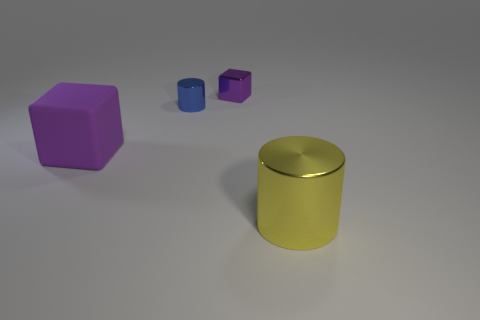There is a rubber object that is the same color as the small metal block; what is its size?
Provide a short and direct response. Large. Is the color of the rubber object the same as the small shiny block?
Your answer should be compact. Yes. Are there fewer blue cylinders that are in front of the rubber thing than large cylinders?
Offer a terse response. Yes. The cylinder that is behind the purple matte object is what color?
Offer a very short reply. Blue. What shape is the tiny blue metal thing?
Keep it short and to the point. Cylinder. Is there a big cylinder in front of the purple block that is in front of the purple metal cube left of the yellow object?
Your answer should be compact. Yes. There is a cube that is left of the tiny object that is behind the shiny cylinder on the left side of the large shiny object; what is its color?
Ensure brevity in your answer.  Purple. There is a large purple object that is the same shape as the small purple object; what is it made of?
Your answer should be very brief. Rubber. There is a purple object left of the cylinder that is behind the large purple rubber block; what is its size?
Offer a terse response. Large. What is the material of the small blue object behind the purple matte cube?
Ensure brevity in your answer.  Metal. 